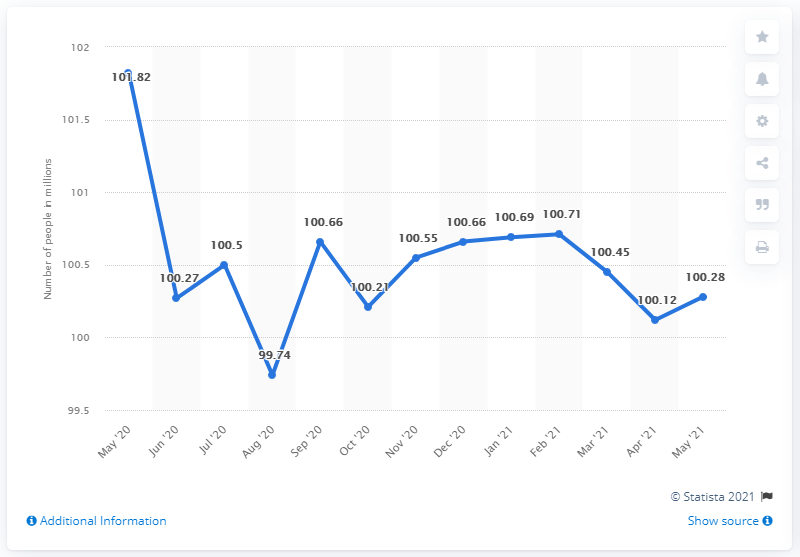What was the lowest point in the inactive labor force during 2020 as shown in the image? The lowest point in the inactive labor force during 2020, as depicted in the image, was in September, when it dropped to approximately 99.74 million people. 